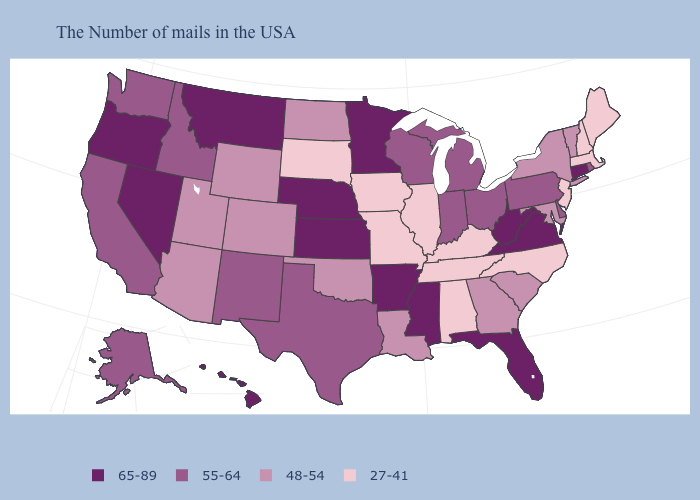Does Maryland have a lower value than North Dakota?
Give a very brief answer. No. Does the map have missing data?
Give a very brief answer. No. Name the states that have a value in the range 48-54?
Write a very short answer. Vermont, New York, Maryland, South Carolina, Georgia, Louisiana, Oklahoma, North Dakota, Wyoming, Colorado, Utah, Arizona. What is the value of Alabama?
Concise answer only. 27-41. Among the states that border Iowa , which have the lowest value?
Give a very brief answer. Illinois, Missouri, South Dakota. What is the value of Utah?
Concise answer only. 48-54. What is the value of North Carolina?
Concise answer only. 27-41. Is the legend a continuous bar?
Answer briefly. No. Which states have the highest value in the USA?
Give a very brief answer. Connecticut, Virginia, West Virginia, Florida, Mississippi, Arkansas, Minnesota, Kansas, Nebraska, Montana, Nevada, Oregon, Hawaii. What is the highest value in the USA?
Concise answer only. 65-89. Which states have the lowest value in the USA?
Give a very brief answer. Maine, Massachusetts, New Hampshire, New Jersey, North Carolina, Kentucky, Alabama, Tennessee, Illinois, Missouri, Iowa, South Dakota. Which states have the lowest value in the USA?
Answer briefly. Maine, Massachusetts, New Hampshire, New Jersey, North Carolina, Kentucky, Alabama, Tennessee, Illinois, Missouri, Iowa, South Dakota. Which states hav the highest value in the Northeast?
Short answer required. Connecticut. Does South Carolina have a lower value than Delaware?
Short answer required. Yes. Does Alabama have the lowest value in the South?
Concise answer only. Yes. 